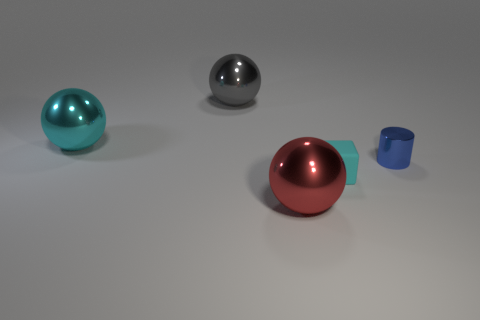Add 4 cyan metallic things. How many objects exist? 9 Subtract all cubes. How many objects are left? 4 Subtract 1 balls. How many balls are left? 2 Subtract all brown spheres. Subtract all yellow cylinders. How many spheres are left? 3 Subtract all small cyan objects. Subtract all small purple matte blocks. How many objects are left? 4 Add 3 cylinders. How many cylinders are left? 4 Add 5 tiny matte blocks. How many tiny matte blocks exist? 6 Subtract 0 green balls. How many objects are left? 5 